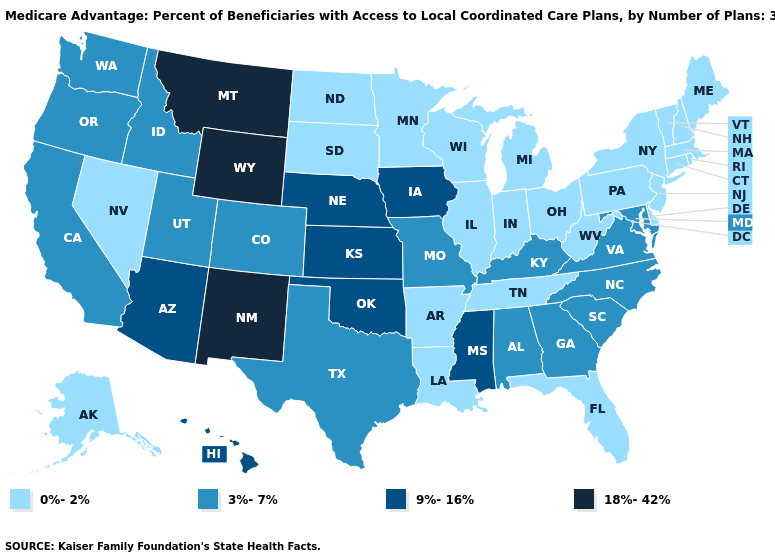Does Maryland have the same value as Ohio?
Be succinct. No. Name the states that have a value in the range 3%-7%?
Keep it brief. Alabama, California, Colorado, Georgia, Idaho, Kentucky, Maryland, Missouri, North Carolina, Oregon, South Carolina, Texas, Utah, Virginia, Washington. What is the value of Missouri?
Write a very short answer. 3%-7%. Which states have the highest value in the USA?
Short answer required. Montana, New Mexico, Wyoming. What is the lowest value in the USA?
Be succinct. 0%-2%. Which states have the highest value in the USA?
Short answer required. Montana, New Mexico, Wyoming. Among the states that border New Mexico , which have the lowest value?
Write a very short answer. Colorado, Texas, Utah. What is the value of New Mexico?
Short answer required. 18%-42%. What is the value of Alabama?
Answer briefly. 3%-7%. Does the map have missing data?
Give a very brief answer. No. Does the map have missing data?
Write a very short answer. No. What is the value of Wyoming?
Write a very short answer. 18%-42%. What is the highest value in the MidWest ?
Concise answer only. 9%-16%. What is the highest value in the USA?
Concise answer only. 18%-42%. What is the value of Oklahoma?
Short answer required. 9%-16%. 